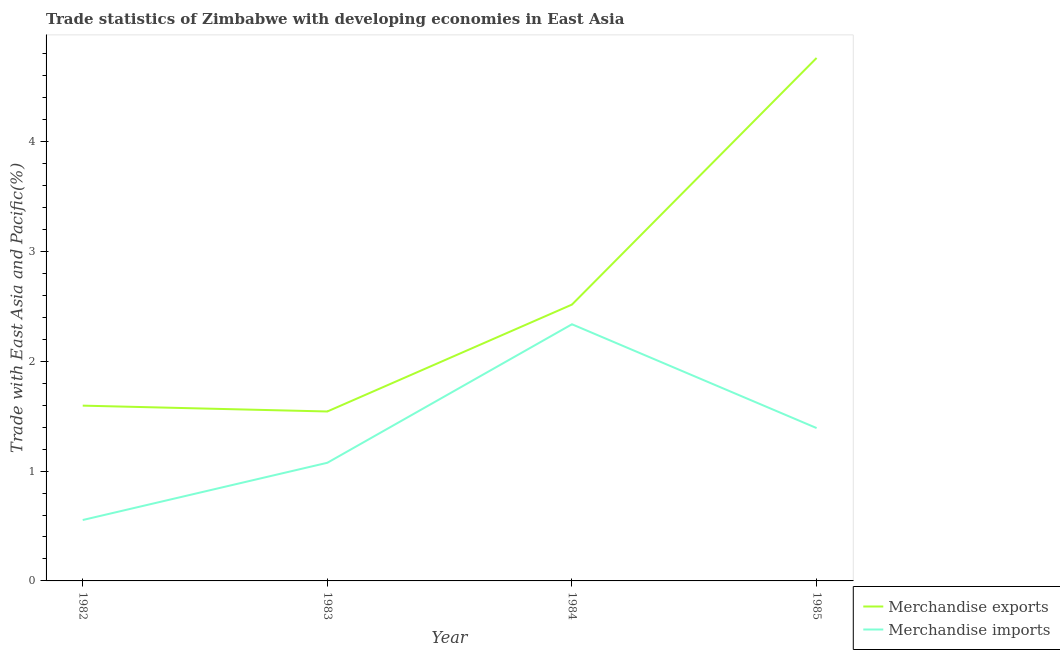Does the line corresponding to merchandise imports intersect with the line corresponding to merchandise exports?
Keep it short and to the point. No. Is the number of lines equal to the number of legend labels?
Ensure brevity in your answer.  Yes. What is the merchandise exports in 1983?
Provide a succinct answer. 1.54. Across all years, what is the maximum merchandise exports?
Your answer should be very brief. 4.76. Across all years, what is the minimum merchandise imports?
Offer a very short reply. 0.55. What is the total merchandise exports in the graph?
Keep it short and to the point. 10.42. What is the difference between the merchandise imports in 1983 and that in 1985?
Give a very brief answer. -0.32. What is the difference between the merchandise imports in 1982 and the merchandise exports in 1984?
Provide a short and direct response. -1.96. What is the average merchandise imports per year?
Offer a very short reply. 1.34. In the year 1984, what is the difference between the merchandise imports and merchandise exports?
Give a very brief answer. -0.18. In how many years, is the merchandise exports greater than 0.2 %?
Offer a very short reply. 4. What is the ratio of the merchandise exports in 1982 to that in 1984?
Offer a terse response. 0.63. Is the merchandise exports in 1982 less than that in 1985?
Ensure brevity in your answer.  Yes. What is the difference between the highest and the second highest merchandise exports?
Ensure brevity in your answer.  2.25. What is the difference between the highest and the lowest merchandise exports?
Offer a very short reply. 3.22. Is the sum of the merchandise exports in 1982 and 1984 greater than the maximum merchandise imports across all years?
Your answer should be very brief. Yes. Is the merchandise exports strictly less than the merchandise imports over the years?
Give a very brief answer. No. How many years are there in the graph?
Give a very brief answer. 4. What is the difference between two consecutive major ticks on the Y-axis?
Ensure brevity in your answer.  1. Does the graph contain grids?
Your response must be concise. No. How are the legend labels stacked?
Ensure brevity in your answer.  Vertical. What is the title of the graph?
Your response must be concise. Trade statistics of Zimbabwe with developing economies in East Asia. What is the label or title of the Y-axis?
Provide a short and direct response. Trade with East Asia and Pacific(%). What is the Trade with East Asia and Pacific(%) of Merchandise exports in 1982?
Your answer should be very brief. 1.6. What is the Trade with East Asia and Pacific(%) in Merchandise imports in 1982?
Offer a terse response. 0.55. What is the Trade with East Asia and Pacific(%) in Merchandise exports in 1983?
Your answer should be very brief. 1.54. What is the Trade with East Asia and Pacific(%) of Merchandise imports in 1983?
Provide a short and direct response. 1.08. What is the Trade with East Asia and Pacific(%) in Merchandise exports in 1984?
Your answer should be compact. 2.52. What is the Trade with East Asia and Pacific(%) of Merchandise imports in 1984?
Provide a succinct answer. 2.34. What is the Trade with East Asia and Pacific(%) of Merchandise exports in 1985?
Make the answer very short. 4.76. What is the Trade with East Asia and Pacific(%) of Merchandise imports in 1985?
Provide a succinct answer. 1.39. Across all years, what is the maximum Trade with East Asia and Pacific(%) in Merchandise exports?
Your answer should be very brief. 4.76. Across all years, what is the maximum Trade with East Asia and Pacific(%) in Merchandise imports?
Provide a succinct answer. 2.34. Across all years, what is the minimum Trade with East Asia and Pacific(%) in Merchandise exports?
Your answer should be compact. 1.54. Across all years, what is the minimum Trade with East Asia and Pacific(%) of Merchandise imports?
Give a very brief answer. 0.55. What is the total Trade with East Asia and Pacific(%) in Merchandise exports in the graph?
Ensure brevity in your answer.  10.42. What is the total Trade with East Asia and Pacific(%) of Merchandise imports in the graph?
Offer a terse response. 5.36. What is the difference between the Trade with East Asia and Pacific(%) in Merchandise exports in 1982 and that in 1983?
Your response must be concise. 0.05. What is the difference between the Trade with East Asia and Pacific(%) in Merchandise imports in 1982 and that in 1983?
Your response must be concise. -0.52. What is the difference between the Trade with East Asia and Pacific(%) of Merchandise exports in 1982 and that in 1984?
Ensure brevity in your answer.  -0.92. What is the difference between the Trade with East Asia and Pacific(%) in Merchandise imports in 1982 and that in 1984?
Provide a short and direct response. -1.78. What is the difference between the Trade with East Asia and Pacific(%) of Merchandise exports in 1982 and that in 1985?
Keep it short and to the point. -3.17. What is the difference between the Trade with East Asia and Pacific(%) of Merchandise imports in 1982 and that in 1985?
Your response must be concise. -0.84. What is the difference between the Trade with East Asia and Pacific(%) of Merchandise exports in 1983 and that in 1984?
Offer a terse response. -0.97. What is the difference between the Trade with East Asia and Pacific(%) of Merchandise imports in 1983 and that in 1984?
Keep it short and to the point. -1.26. What is the difference between the Trade with East Asia and Pacific(%) in Merchandise exports in 1983 and that in 1985?
Ensure brevity in your answer.  -3.22. What is the difference between the Trade with East Asia and Pacific(%) in Merchandise imports in 1983 and that in 1985?
Provide a short and direct response. -0.32. What is the difference between the Trade with East Asia and Pacific(%) in Merchandise exports in 1984 and that in 1985?
Offer a very short reply. -2.25. What is the difference between the Trade with East Asia and Pacific(%) in Merchandise imports in 1984 and that in 1985?
Your answer should be compact. 0.95. What is the difference between the Trade with East Asia and Pacific(%) in Merchandise exports in 1982 and the Trade with East Asia and Pacific(%) in Merchandise imports in 1983?
Provide a succinct answer. 0.52. What is the difference between the Trade with East Asia and Pacific(%) in Merchandise exports in 1982 and the Trade with East Asia and Pacific(%) in Merchandise imports in 1984?
Offer a terse response. -0.74. What is the difference between the Trade with East Asia and Pacific(%) of Merchandise exports in 1982 and the Trade with East Asia and Pacific(%) of Merchandise imports in 1985?
Ensure brevity in your answer.  0.2. What is the difference between the Trade with East Asia and Pacific(%) of Merchandise exports in 1983 and the Trade with East Asia and Pacific(%) of Merchandise imports in 1984?
Provide a short and direct response. -0.79. What is the difference between the Trade with East Asia and Pacific(%) of Merchandise exports in 1983 and the Trade with East Asia and Pacific(%) of Merchandise imports in 1985?
Ensure brevity in your answer.  0.15. What is the difference between the Trade with East Asia and Pacific(%) of Merchandise exports in 1984 and the Trade with East Asia and Pacific(%) of Merchandise imports in 1985?
Provide a succinct answer. 1.12. What is the average Trade with East Asia and Pacific(%) of Merchandise exports per year?
Give a very brief answer. 2.6. What is the average Trade with East Asia and Pacific(%) of Merchandise imports per year?
Keep it short and to the point. 1.34. In the year 1982, what is the difference between the Trade with East Asia and Pacific(%) in Merchandise exports and Trade with East Asia and Pacific(%) in Merchandise imports?
Provide a short and direct response. 1.04. In the year 1983, what is the difference between the Trade with East Asia and Pacific(%) in Merchandise exports and Trade with East Asia and Pacific(%) in Merchandise imports?
Your response must be concise. 0.47. In the year 1984, what is the difference between the Trade with East Asia and Pacific(%) of Merchandise exports and Trade with East Asia and Pacific(%) of Merchandise imports?
Ensure brevity in your answer.  0.18. In the year 1985, what is the difference between the Trade with East Asia and Pacific(%) of Merchandise exports and Trade with East Asia and Pacific(%) of Merchandise imports?
Offer a very short reply. 3.37. What is the ratio of the Trade with East Asia and Pacific(%) of Merchandise exports in 1982 to that in 1983?
Your answer should be very brief. 1.03. What is the ratio of the Trade with East Asia and Pacific(%) in Merchandise imports in 1982 to that in 1983?
Make the answer very short. 0.52. What is the ratio of the Trade with East Asia and Pacific(%) in Merchandise exports in 1982 to that in 1984?
Your answer should be compact. 0.63. What is the ratio of the Trade with East Asia and Pacific(%) of Merchandise imports in 1982 to that in 1984?
Provide a short and direct response. 0.24. What is the ratio of the Trade with East Asia and Pacific(%) in Merchandise exports in 1982 to that in 1985?
Your answer should be compact. 0.34. What is the ratio of the Trade with East Asia and Pacific(%) of Merchandise imports in 1982 to that in 1985?
Provide a short and direct response. 0.4. What is the ratio of the Trade with East Asia and Pacific(%) in Merchandise exports in 1983 to that in 1984?
Your answer should be compact. 0.61. What is the ratio of the Trade with East Asia and Pacific(%) of Merchandise imports in 1983 to that in 1984?
Keep it short and to the point. 0.46. What is the ratio of the Trade with East Asia and Pacific(%) of Merchandise exports in 1983 to that in 1985?
Make the answer very short. 0.32. What is the ratio of the Trade with East Asia and Pacific(%) in Merchandise imports in 1983 to that in 1985?
Give a very brief answer. 0.77. What is the ratio of the Trade with East Asia and Pacific(%) in Merchandise exports in 1984 to that in 1985?
Keep it short and to the point. 0.53. What is the ratio of the Trade with East Asia and Pacific(%) in Merchandise imports in 1984 to that in 1985?
Provide a short and direct response. 1.68. What is the difference between the highest and the second highest Trade with East Asia and Pacific(%) in Merchandise exports?
Make the answer very short. 2.25. What is the difference between the highest and the second highest Trade with East Asia and Pacific(%) in Merchandise imports?
Offer a terse response. 0.95. What is the difference between the highest and the lowest Trade with East Asia and Pacific(%) of Merchandise exports?
Offer a terse response. 3.22. What is the difference between the highest and the lowest Trade with East Asia and Pacific(%) in Merchandise imports?
Your answer should be compact. 1.78. 